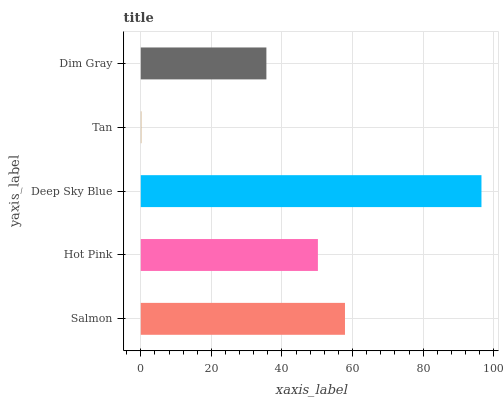Is Tan the minimum?
Answer yes or no. Yes. Is Deep Sky Blue the maximum?
Answer yes or no. Yes. Is Hot Pink the minimum?
Answer yes or no. No. Is Hot Pink the maximum?
Answer yes or no. No. Is Salmon greater than Hot Pink?
Answer yes or no. Yes. Is Hot Pink less than Salmon?
Answer yes or no. Yes. Is Hot Pink greater than Salmon?
Answer yes or no. No. Is Salmon less than Hot Pink?
Answer yes or no. No. Is Hot Pink the high median?
Answer yes or no. Yes. Is Hot Pink the low median?
Answer yes or no. Yes. Is Dim Gray the high median?
Answer yes or no. No. Is Dim Gray the low median?
Answer yes or no. No. 